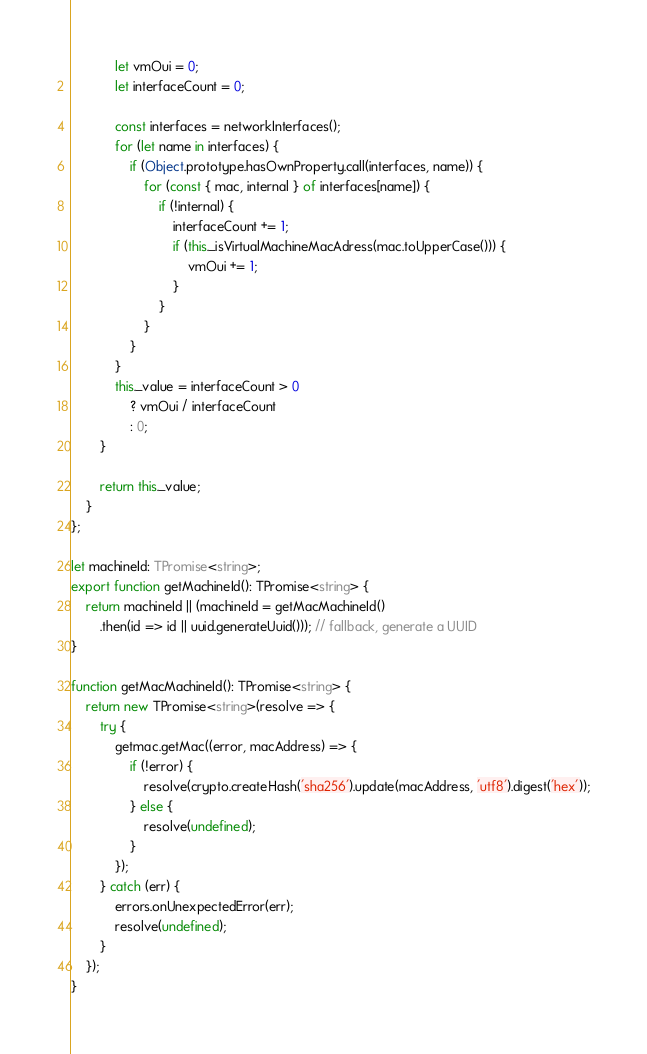Convert code to text. <code><loc_0><loc_0><loc_500><loc_500><_TypeScript_>			let vmOui = 0;
			let interfaceCount = 0;

			const interfaces = networkInterfaces();
			for (let name in interfaces) {
				if (Object.prototype.hasOwnProperty.call(interfaces, name)) {
					for (const { mac, internal } of interfaces[name]) {
						if (!internal) {
							interfaceCount += 1;
							if (this._isVirtualMachineMacAdress(mac.toUpperCase())) {
								vmOui += 1;
							}
						}
					}
				}
			}
			this._value = interfaceCount > 0
				? vmOui / interfaceCount
				: 0;
		}

		return this._value;
	}
};

let machineId: TPromise<string>;
export function getMachineId(): TPromise<string> {
	return machineId || (machineId = getMacMachineId()
		.then(id => id || uuid.generateUuid())); // fallback, generate a UUID
}

function getMacMachineId(): TPromise<string> {
	return new TPromise<string>(resolve => {
		try {
			getmac.getMac((error, macAddress) => {
				if (!error) {
					resolve(crypto.createHash('sha256').update(macAddress, 'utf8').digest('hex'));
				} else {
					resolve(undefined);
				}
			});
		} catch (err) {
			errors.onUnexpectedError(err);
			resolve(undefined);
		}
	});
}
</code> 